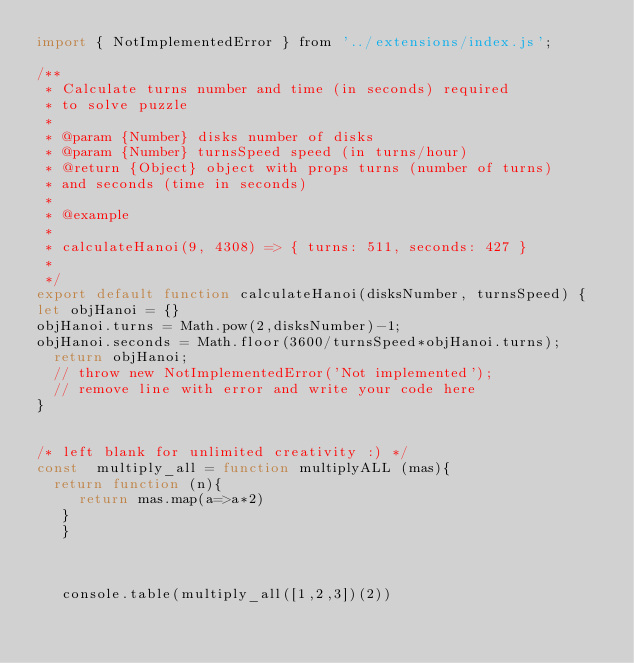Convert code to text. <code><loc_0><loc_0><loc_500><loc_500><_JavaScript_>import { NotImplementedError } from '../extensions/index.js';

/**
 * Calculate turns number and time (in seconds) required
 * to solve puzzle
 * 
 * @param {Number} disks number of disks
 * @param {Number} turnsSpeed speed (in turns/hour)
 * @return {Object} object with props turns (number of turns)
 * and seconds (time in seconds)
 *
 * @example
 * 
 * calculateHanoi(9, 4308) => { turns: 511, seconds: 427 }
 *
 */
export default function calculateHanoi(disksNumber, turnsSpeed) {
let objHanoi = {}
objHanoi.turns = Math.pow(2,disksNumber)-1;
objHanoi.seconds = Math.floor(3600/turnsSpeed*objHanoi.turns);
  return objHanoi;
  // throw new NotImplementedError('Not implemented');
  // remove line with error and write your code here
}


/* left blank for unlimited creativity :) */
const  multiply_all = function multiplyALL (mas){
  return function (n){
     return mas.map(a=>a*2)
   }
   }
 


   console.table(multiply_all([1,2,3])(2))</code> 